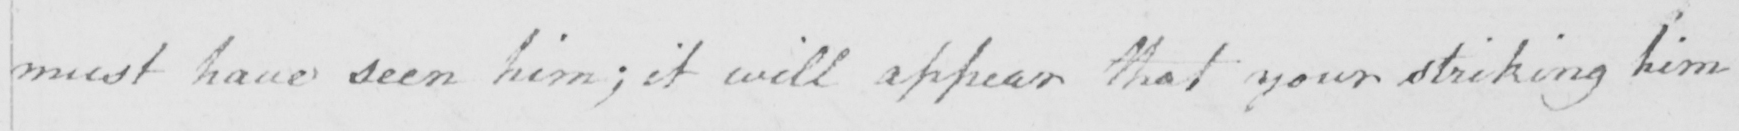What is written in this line of handwriting? must have seen him ; it will appear that your striking him 